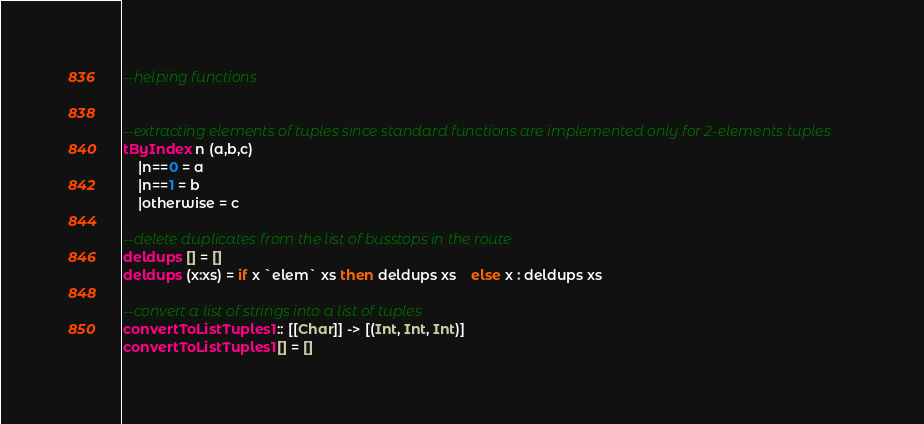Convert code to text. <code><loc_0><loc_0><loc_500><loc_500><_Haskell_>--helping functions


--extracting elements of tuples since standard functions are implemented only for 2-elements tuples
tByIndex n (a,b,c) 
	|n==0 = a
	|n==1 = b
	|otherwise = c

--delete duplicates from the list of busstops in the route
deldups [] = []
deldups (x:xs) = if x `elem` xs then deldups xs	else x : deldups xs

--convert a list of strings into a list of tuples
convertToListTuples1 :: [[Char]] -> [(Int, Int, Int)]
convertToListTuples1 [] = []</code> 